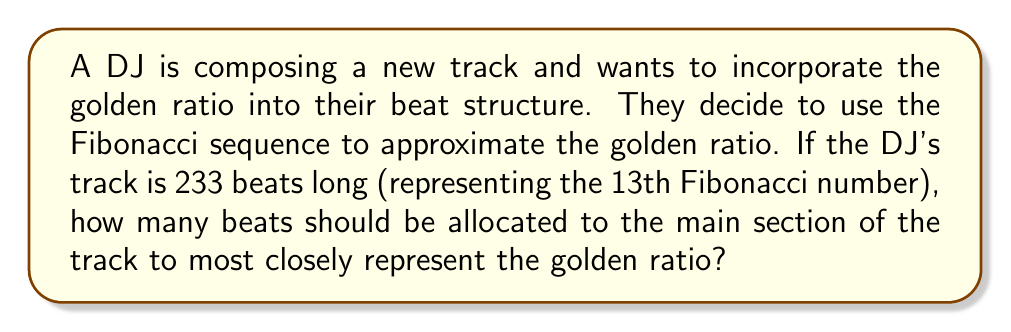Provide a solution to this math problem. Let's approach this step-by-step:

1) The golden ratio, denoted by φ (phi), is approximately 1.618034.

2) The Fibonacci sequence approximates the golden ratio as we move to higher terms. The ratio of consecutive Fibonacci numbers approaches φ.

3) In this case, we have 233 beats total, which is the 13th Fibonacci number.

4) To find the number of beats for the main section that best represents the golden ratio, we need to divide the total number of beats by φ:

   $$ \text{Main section beats} = \frac{\text{Total beats}}{\phi} $$

5) Substituting our values:

   $$ \text{Main section beats} = \frac{233}{1.618034} \approx 144.00 $$

6) Since we can't have a fractional beat, we round to the nearest whole number:

   $$ \text{Main section beats} = 144 $$

7) Interestingly, 144 is also a Fibonacci number (the 12th in the sequence).

8) We can verify this approximates the golden ratio:

   $$ \frac{233}{144} \approx 1.618056 $$

   Which is very close to φ (1.618034).

This division of 233 into 144 and 89 (233 - 144) beats reflects the golden ratio in the track's structure, potentially creating a pleasing rhythmic balance that subconsciously resonates with listeners.
Answer: 144 beats 